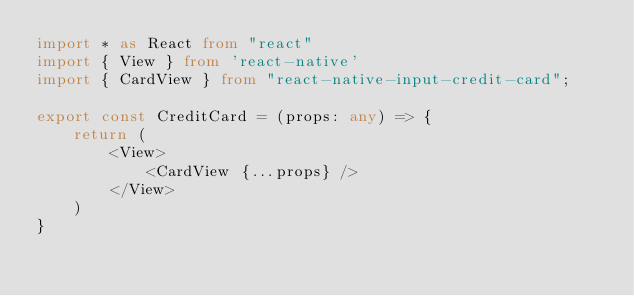<code> <loc_0><loc_0><loc_500><loc_500><_TypeScript_>import * as React from "react"
import { View } from 'react-native'
import { CardView } from "react-native-input-credit-card";

export const CreditCard = (props: any) => {
    return (
        <View>
            <CardView {...props} />
        </View>
    )
}</code> 